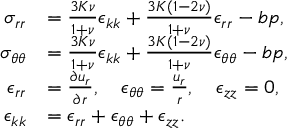Convert formula to latex. <formula><loc_0><loc_0><loc_500><loc_500>\begin{array} { r l } { \sigma _ { r r } } & { = \frac { 3 K \nu } { 1 + \nu } \epsilon _ { k k } + \frac { 3 K ( 1 - 2 \nu ) } { 1 + \nu } \epsilon _ { r r } - b p , } \\ { \sigma _ { \theta \theta } } & { = \frac { 3 K \nu } { 1 + \nu } \epsilon _ { k k } + \frac { 3 K ( 1 - 2 \nu ) } { 1 + \nu } \epsilon _ { \theta \theta } - b p , } \\ { \epsilon _ { r r } } & { = \frac { \partial u _ { r } } { \partial r } , \quad \epsilon _ { \theta \theta } = \frac { u _ { r } } { r } , \quad \epsilon _ { z z } = 0 , } \\ { \epsilon _ { k k } } & { = \epsilon _ { r r } + \epsilon _ { \theta \theta } + \epsilon _ { z z } . } \end{array}</formula> 